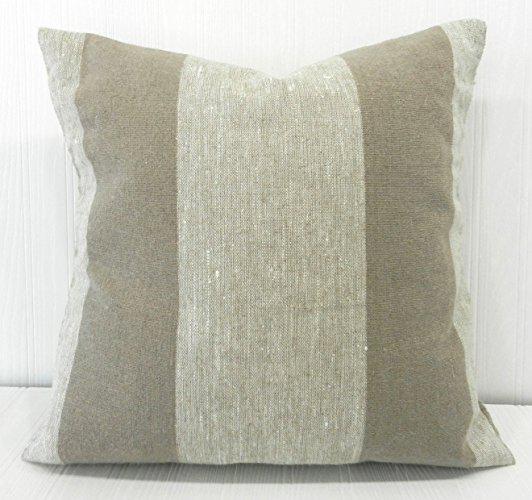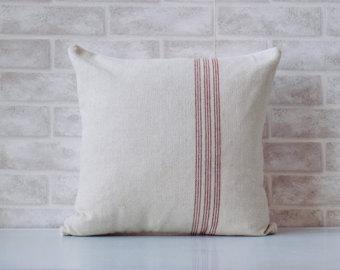The first image is the image on the left, the second image is the image on the right. Evaluate the accuracy of this statement regarding the images: "One image features a white square pillow with three button closure that is propped against the back of a white chair.". Is it true? Answer yes or no. No. The first image is the image on the left, the second image is the image on the right. For the images displayed, is the sentence "The pillow in one of the images has three buttons." factually correct? Answer yes or no. No. 